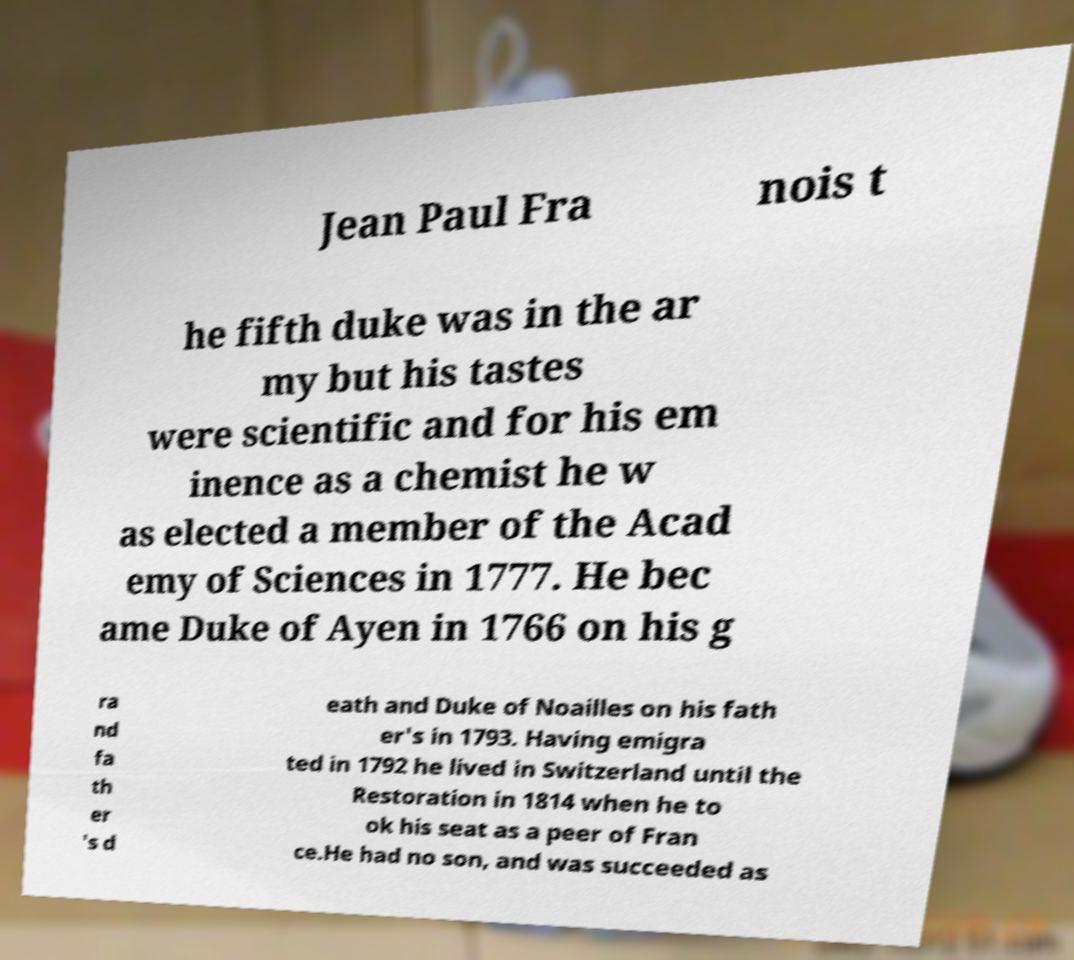What messages or text are displayed in this image? I need them in a readable, typed format. Jean Paul Fra nois t he fifth duke was in the ar my but his tastes were scientific and for his em inence as a chemist he w as elected a member of the Acad emy of Sciences in 1777. He bec ame Duke of Ayen in 1766 on his g ra nd fa th er 's d eath and Duke of Noailles on his fath er's in 1793. Having emigra ted in 1792 he lived in Switzerland until the Restoration in 1814 when he to ok his seat as a peer of Fran ce.He had no son, and was succeeded as 